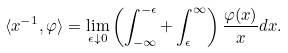<formula> <loc_0><loc_0><loc_500><loc_500>\langle x ^ { - 1 } , \varphi \rangle = \lim _ { \epsilon \downarrow 0 } \left ( \int _ { - \infty } ^ { - \epsilon } + \int _ { \epsilon } ^ { \infty } \right ) \frac { \varphi ( x ) } { x } d x .</formula> 